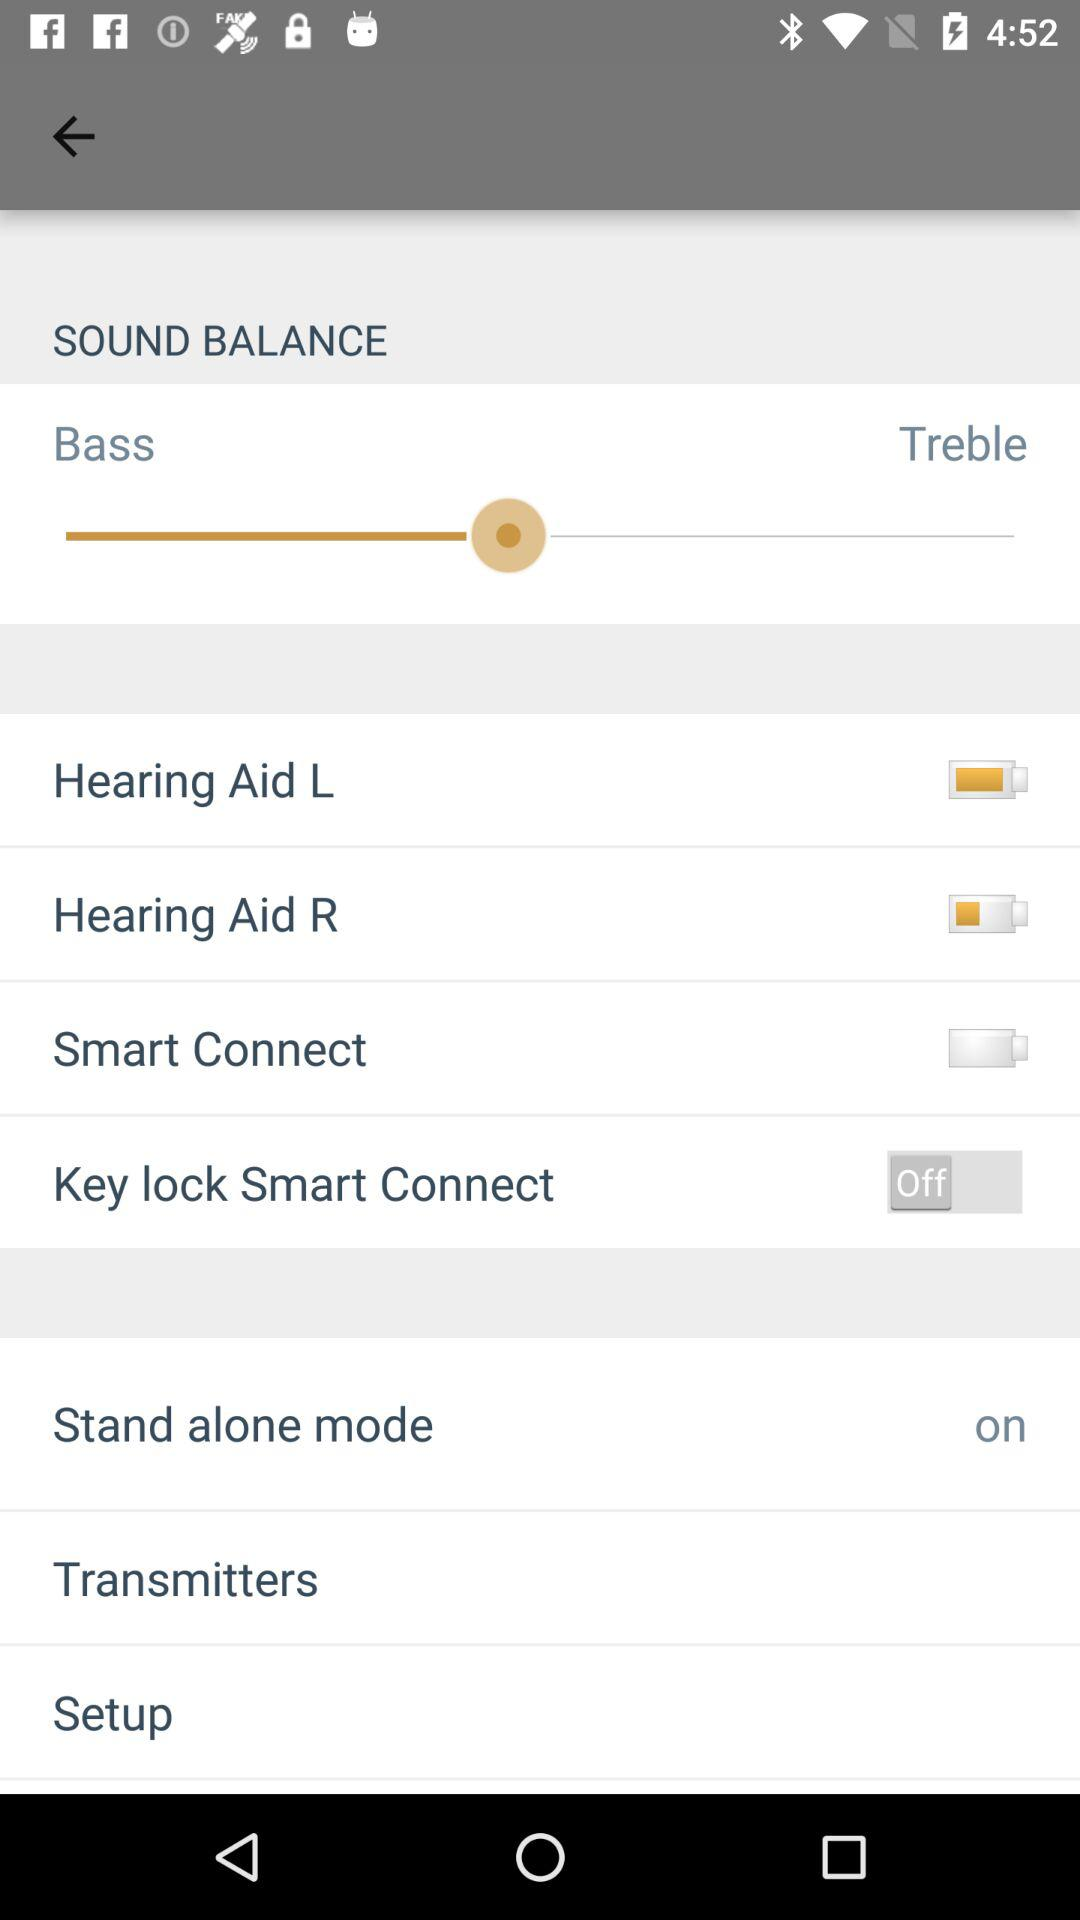What is the setting for "Stand alone mode"? The setting for "Stand alone mode" is "on". 